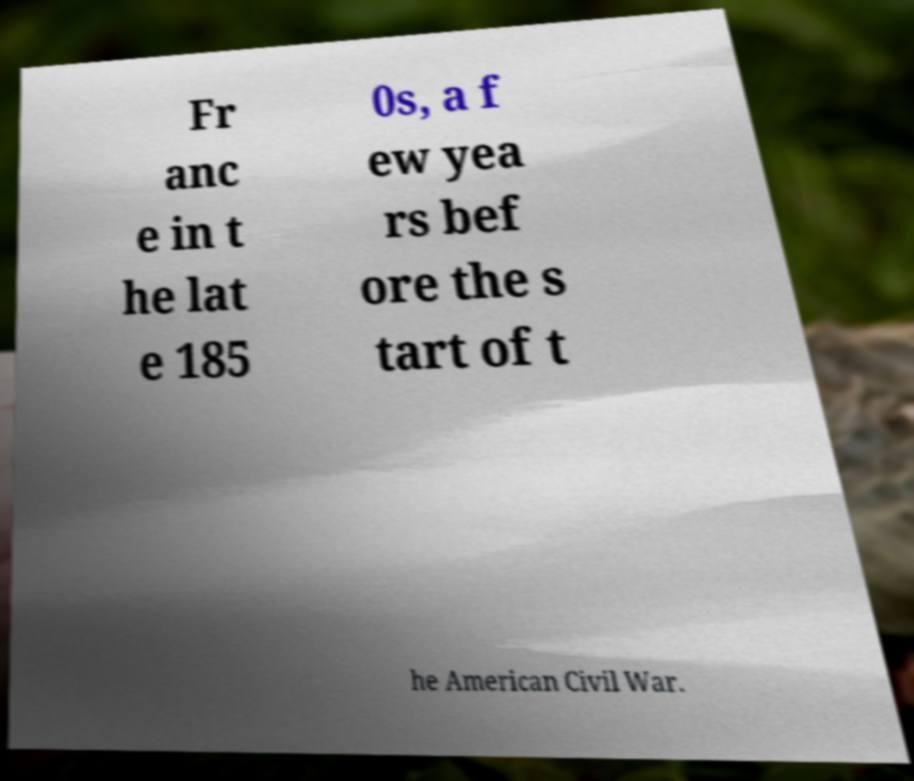Could you assist in decoding the text presented in this image and type it out clearly? Fr anc e in t he lat e 185 0s, a f ew yea rs bef ore the s tart of t he American Civil War. 